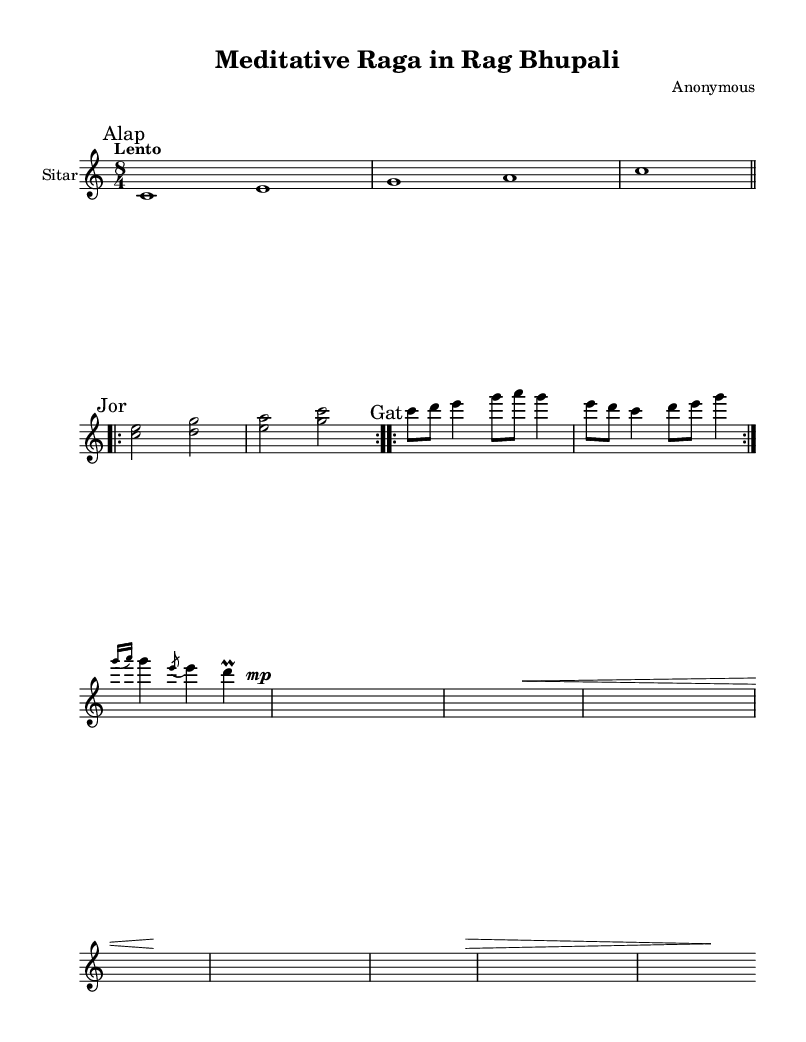What is the title of this piece? The title is specified in the header section of the sheet music, which is "Meditative Raga in Rag Bhupali."
Answer: Meditative Raga in Rag Bhupali What is the time signature of the music? The time signature is found in the global variable section, indicated as 8/4. This means there are eight beats per measure, with the quarter note getting the beat.
Answer: 8/4 What tempo marking is given for this composition? The tempo marking is explicitly stated in the global section as "Lento," which indicates a slow pace.
Answer: Lento What does "Alap" signify in this piece? "Alap" is marked in the sheet music and refers to the introductory section of a raga, that is usually performed in free time without rhythm.
Answer: Alap Which ornamentation technique is used in this composition? The ornamentation techniques included in the music are a grace note (notated with g16(a)) and an acciaccatura (notated with e8). These embellishments decorate the melody.
Answer: Grace note and acciaccatura How many times is the "Jor" section repeated? The repetition of the "Jor" section is indicated by the 'repeat volta 2' marking, meaning this section is played twice before moving on to the next section.
Answer: 2 What key is this piece composed in? The key signature is detailed in the global variable as "c major," indicating that there are no sharps or flats.
Answer: C major 